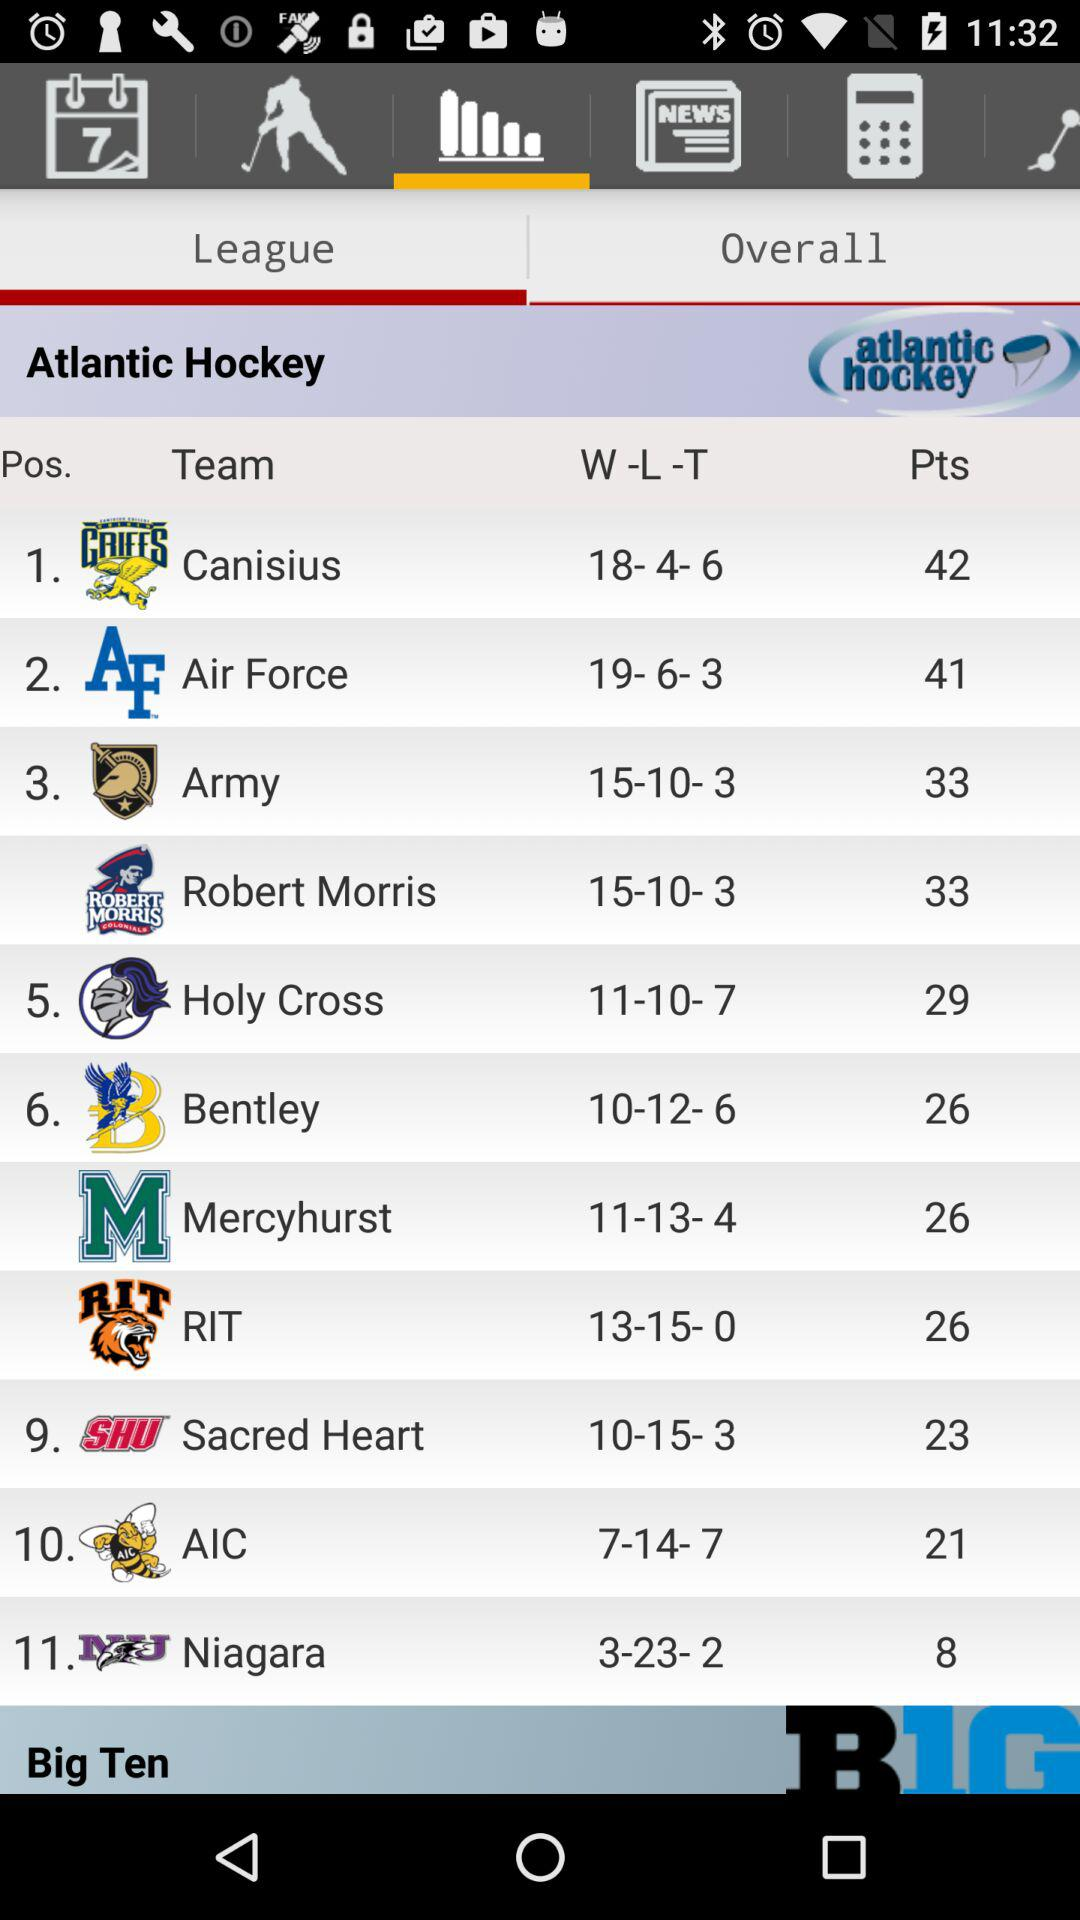What is the "W -L -T" of the team AIC in the hockey league? The "W -L -T" is 7-14- 7. 